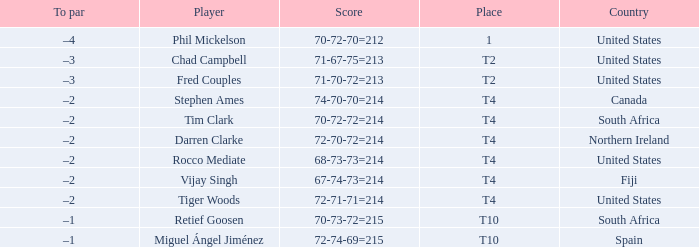What country is Chad Campbell from? United States. 